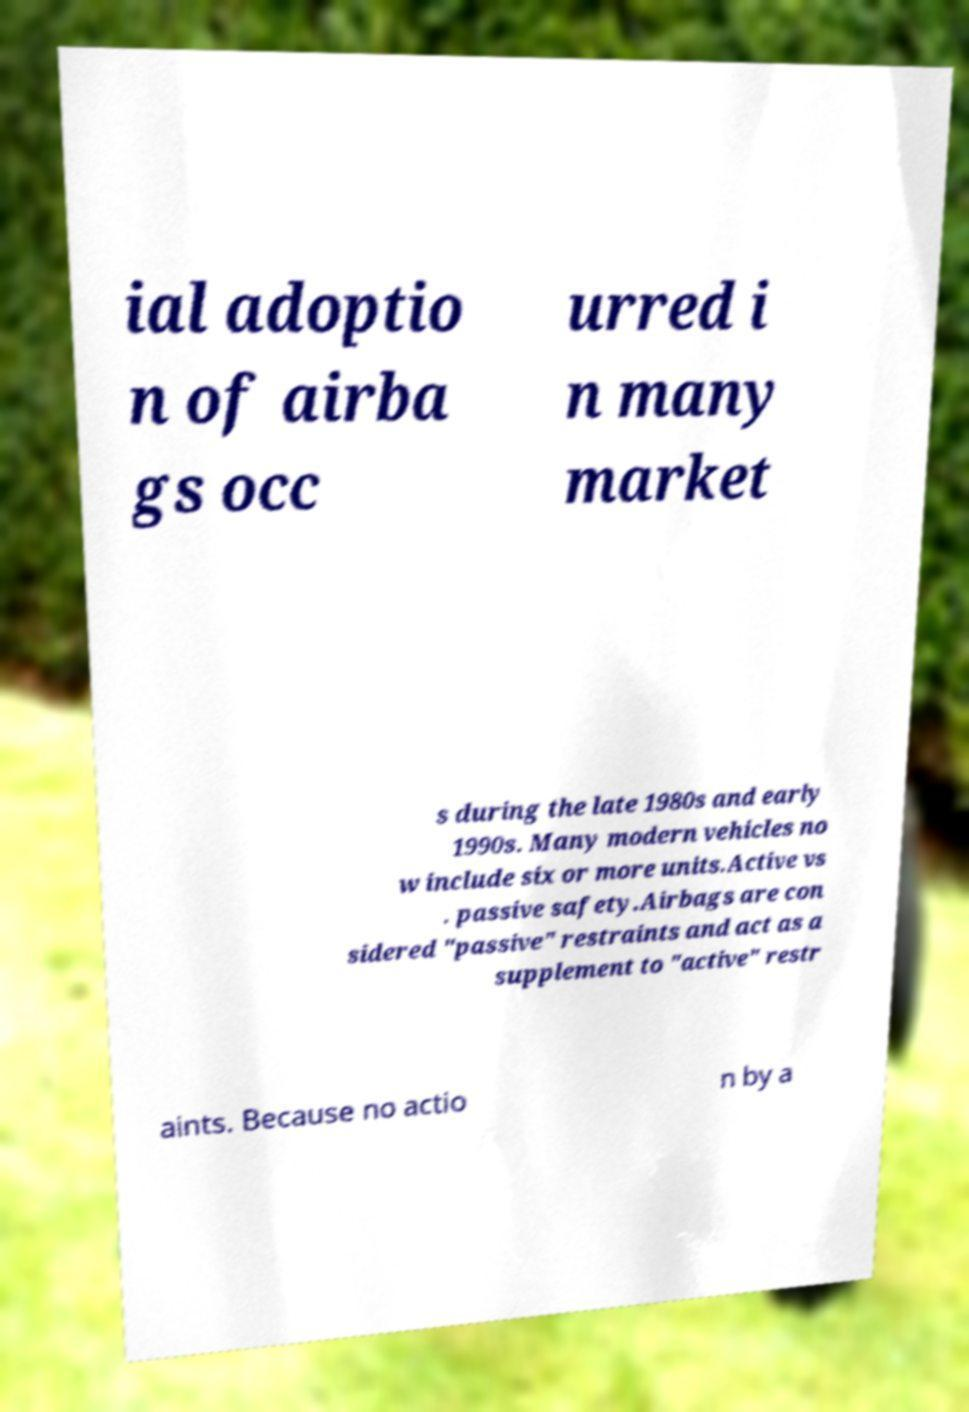Can you read and provide the text displayed in the image?This photo seems to have some interesting text. Can you extract and type it out for me? ial adoptio n of airba gs occ urred i n many market s during the late 1980s and early 1990s. Many modern vehicles no w include six or more units.Active vs . passive safety.Airbags are con sidered "passive" restraints and act as a supplement to "active" restr aints. Because no actio n by a 